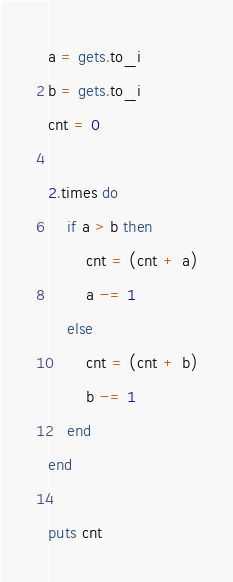<code> <loc_0><loc_0><loc_500><loc_500><_Ruby_>a = gets.to_i
b = gets.to_i
cnt = 0

2.times do
    if a > b then
        cnt = (cnt + a)
        a -= 1
    else
        cnt = (cnt + b)
        b -= 1
    end
end

puts cnt</code> 